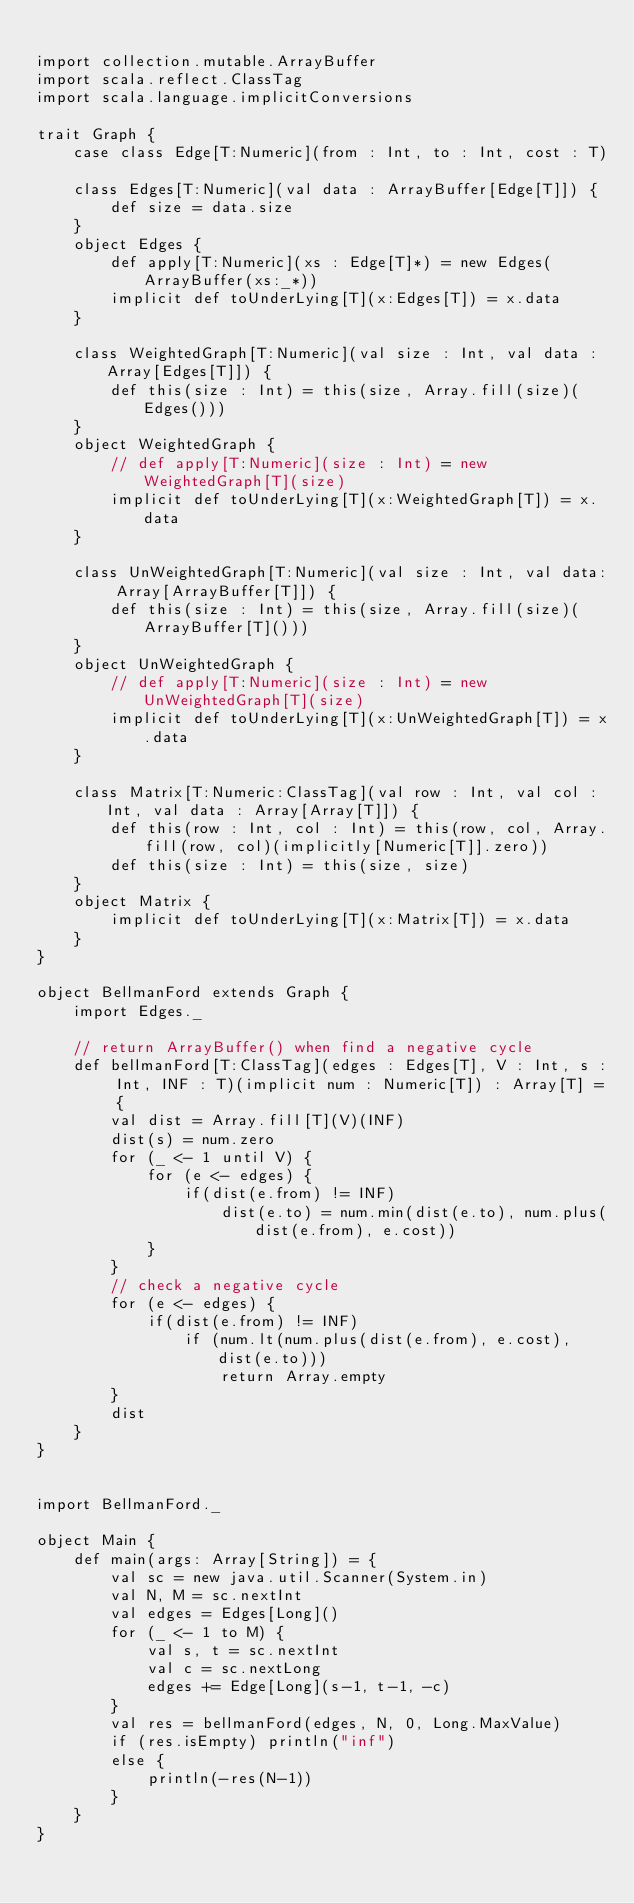Convert code to text. <code><loc_0><loc_0><loc_500><loc_500><_Scala_>
import collection.mutable.ArrayBuffer
import scala.reflect.ClassTag
import scala.language.implicitConversions

trait Graph { 
    case class Edge[T:Numeric](from : Int, to : Int, cost : T)

    class Edges[T:Numeric](val data : ArrayBuffer[Edge[T]]) {
        def size = data.size
    }
    object Edges {
        def apply[T:Numeric](xs : Edge[T]*) = new Edges(ArrayBuffer(xs:_*))
        implicit def toUnderLying[T](x:Edges[T]) = x.data
    }

    class WeightedGraph[T:Numeric](val size : Int, val data : Array[Edges[T]]) {
        def this(size : Int) = this(size, Array.fill(size)(Edges()))
    }
    object WeightedGraph {
        // def apply[T:Numeric](size : Int) = new WeightedGraph[T](size)
        implicit def toUnderLying[T](x:WeightedGraph[T]) = x.data
    }

    class UnWeightedGraph[T:Numeric](val size : Int, val data: Array[ArrayBuffer[T]]) {
        def this(size : Int) = this(size, Array.fill(size)(ArrayBuffer[T]()))
    }
    object UnWeightedGraph {
        // def apply[T:Numeric](size : Int) = new UnWeightedGraph[T](size)
        implicit def toUnderLying[T](x:UnWeightedGraph[T]) = x.data
    }
   
    class Matrix[T:Numeric:ClassTag](val row : Int, val col : Int, val data : Array[Array[T]]) {
        def this(row : Int, col : Int) = this(row, col, Array.fill(row, col)(implicitly[Numeric[T]].zero))
        def this(size : Int) = this(size, size)
    }
    object Matrix {
        implicit def toUnderLying[T](x:Matrix[T]) = x.data
    }
}

object BellmanFord extends Graph {
    import Edges._

    // return ArrayBuffer() when find a negative cycle
    def bellmanFord[T:ClassTag](edges : Edges[T], V : Int, s : Int, INF : T)(implicit num : Numeric[T]) : Array[T] = {
        val dist = Array.fill[T](V)(INF)
        dist(s) = num.zero
        for (_ <- 1 until V) {
            for (e <- edges) {
                if(dist(e.from) != INF) 
                    dist(e.to) = num.min(dist(e.to), num.plus(dist(e.from), e.cost))
            }
        }
        // check a negative cycle
        for (e <- edges) {
            if(dist(e.from) != INF) 
                if (num.lt(num.plus(dist(e.from), e.cost), dist(e.to)))
                    return Array.empty
        }
        dist
    }
}


import BellmanFord._

object Main {
    def main(args: Array[String]) = {
        val sc = new java.util.Scanner(System.in)
        val N, M = sc.nextInt
        val edges = Edges[Long]()
        for (_ <- 1 to M) {
            val s, t = sc.nextInt
            val c = sc.nextLong
            edges += Edge[Long](s-1, t-1, -c)
        }
        val res = bellmanFord(edges, N, 0, Long.MaxValue)
        if (res.isEmpty) println("inf")
        else {
            println(-res(N-1))
        }
    }
}</code> 